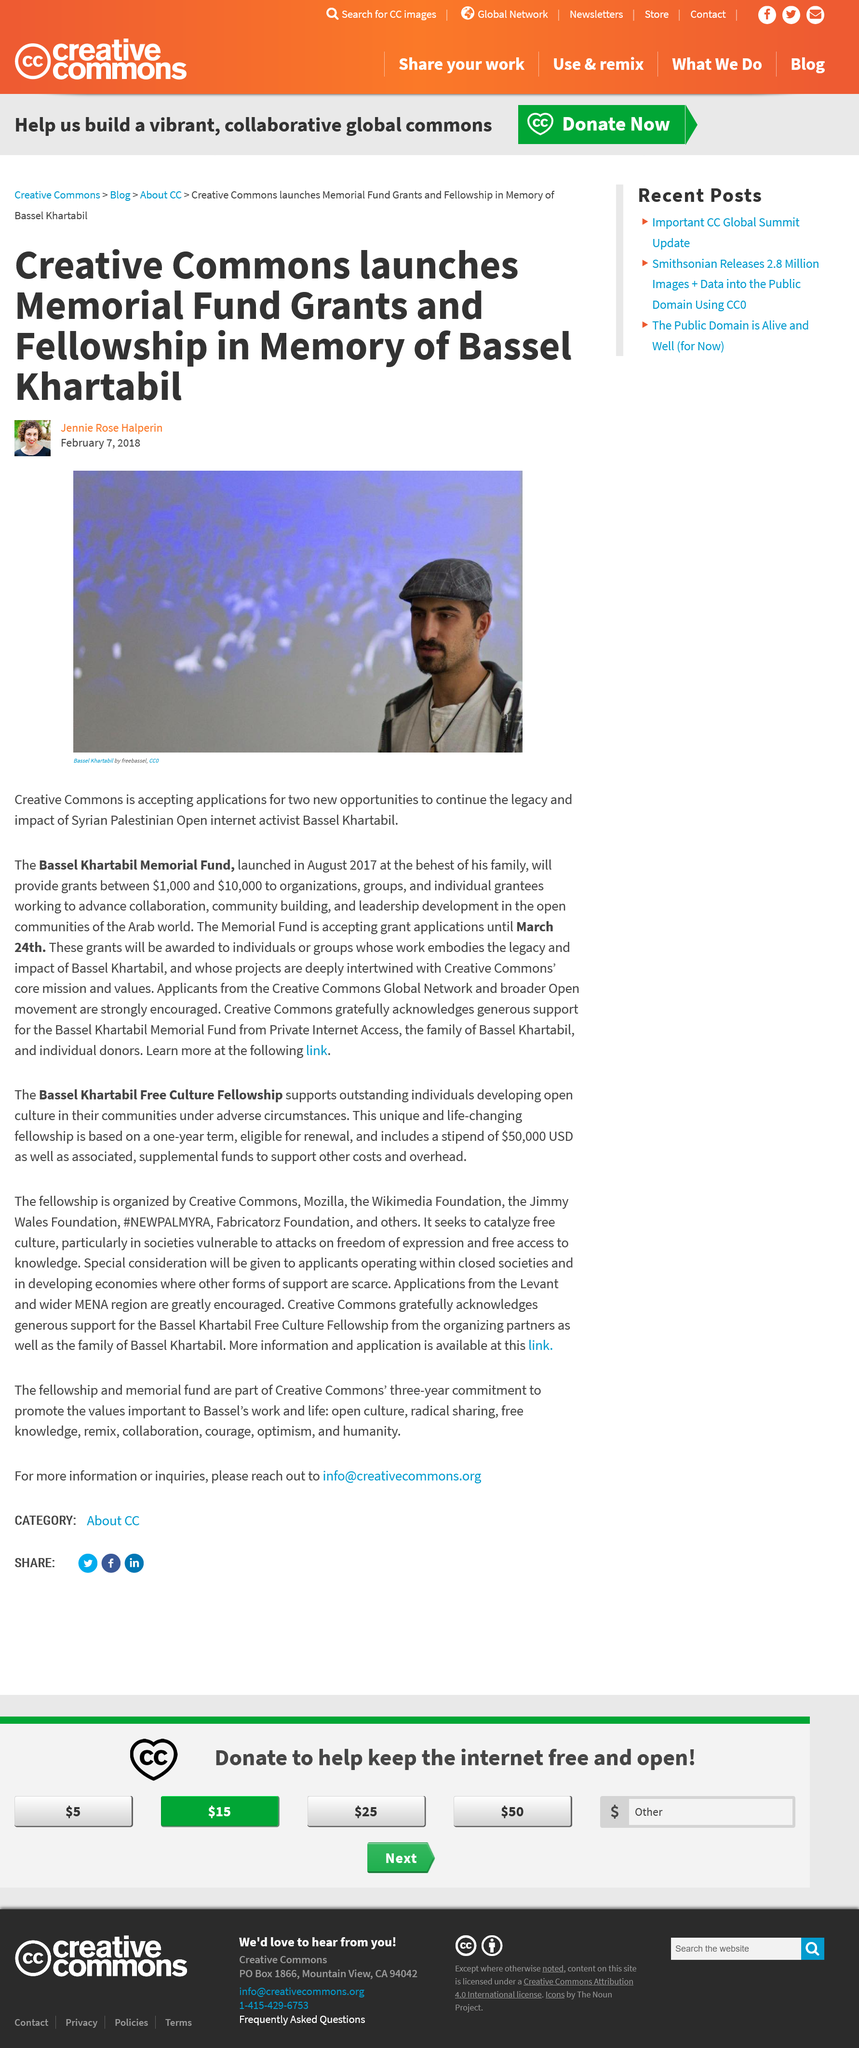Highlight a few significant elements in this photo. The article titled "Memorial Fund Grants and Fellowship in Memory of Bassel Khartabil" was written by Jennie Rose Halperin. Bassel Khartabil is the name of an internet activist. Creative Commons is currently offering two opportunities to continue the legacy and impact of Syrian Palestinian Open activist Bassel Khartabil, including the chance to continue his important work in the field of open access and free knowledge. 